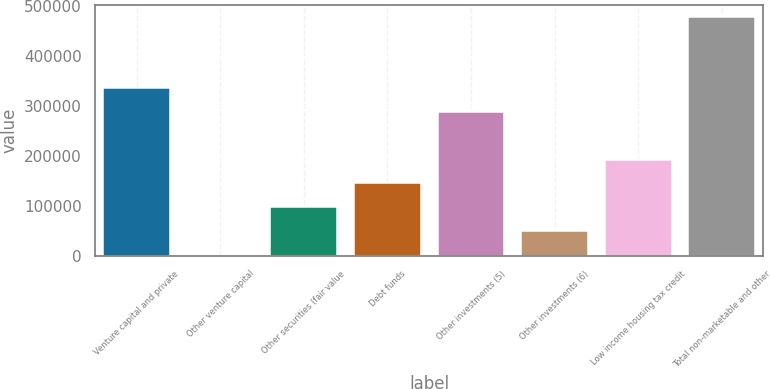<chart> <loc_0><loc_0><loc_500><loc_500><bar_chart><fcel>Venture capital and private<fcel>Other venture capital<fcel>Other securities (fair value<fcel>Debt funds<fcel>Other investments (5)<fcel>Other investments (6)<fcel>Low income housing tax credit<fcel>Total non-marketable and other<nl><fcel>335838<fcel>2097<fcel>97451.6<fcel>145129<fcel>288161<fcel>49774.3<fcel>192806<fcel>478870<nl></chart> 